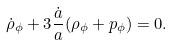Convert formula to latex. <formula><loc_0><loc_0><loc_500><loc_500>\dot { \rho } _ { \phi } + 3 \frac { \dot { a } } { a } ( \rho _ { \phi } + p _ { \phi } ) = 0 .</formula> 